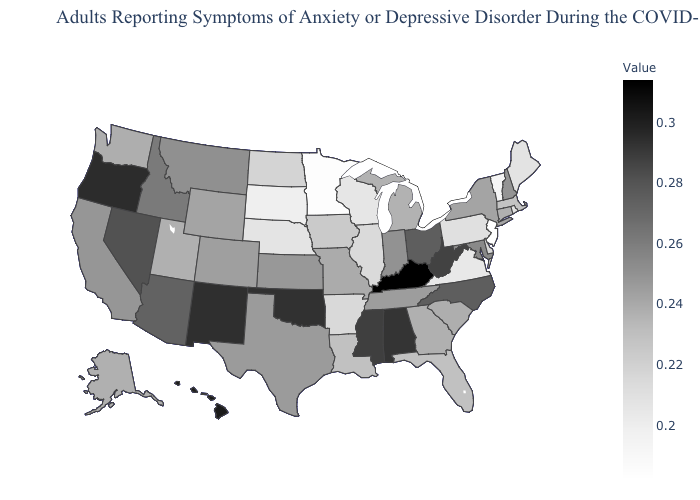Does Ohio have a higher value than Kentucky?
Quick response, please. No. Which states have the lowest value in the MidWest?
Concise answer only. Minnesota. Is the legend a continuous bar?
Keep it brief. Yes. Does South Carolina have the highest value in the USA?
Short answer required. No. Does Vermont have the highest value in the Northeast?
Quick response, please. No. 